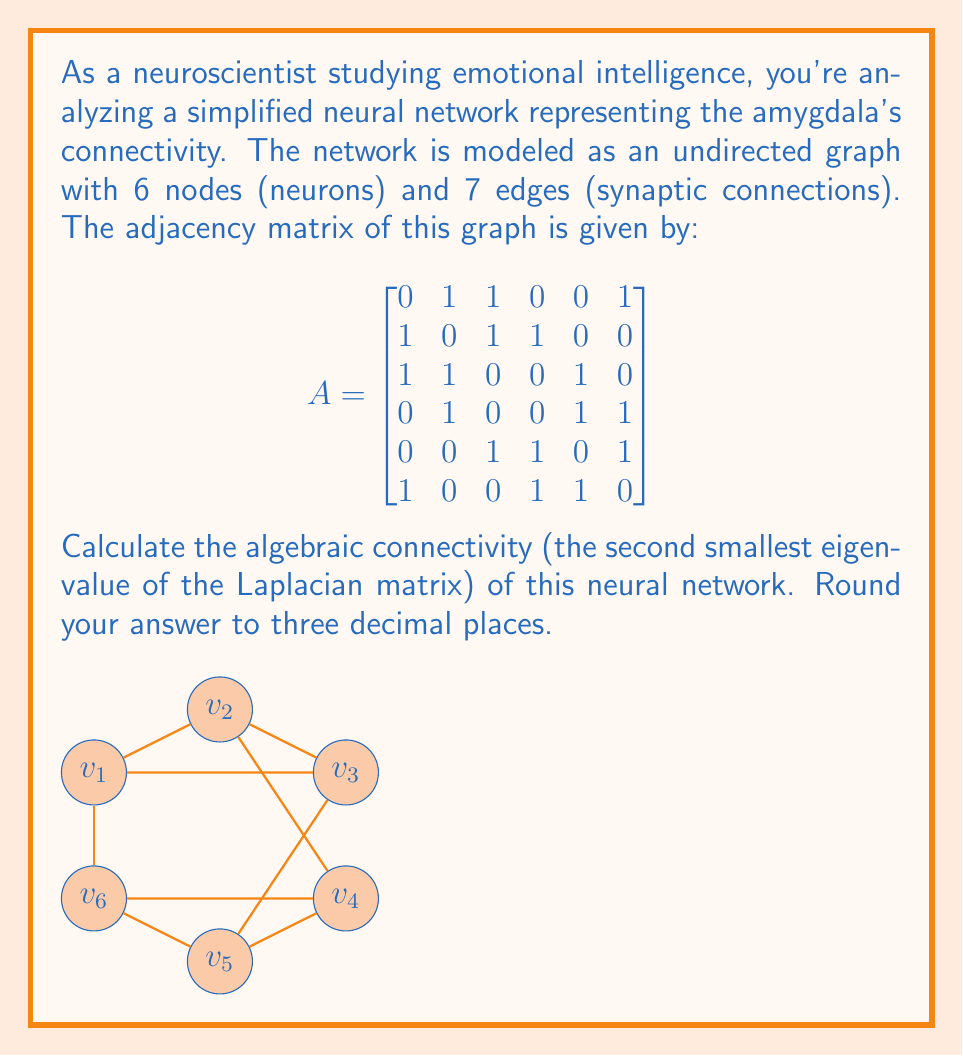Solve this math problem. To solve this problem, we'll follow these steps:

1) First, we need to compute the Laplacian matrix L from the adjacency matrix A.
   $L = D - A$, where D is the degree matrix.

2) The degree matrix D is a diagonal matrix where $D_{ii}$ is the degree of vertex i:
   $$D = \begin{bmatrix}
   3 & 0 & 0 & 0 & 0 & 0 \\
   0 & 3 & 0 & 0 & 0 & 0 \\
   0 & 0 & 3 & 0 & 0 & 0 \\
   0 & 0 & 0 & 3 & 0 & 0 \\
   0 & 0 & 0 & 0 & 3 & 0 \\
   0 & 0 & 0 & 0 & 0 & 3
   \end{bmatrix}$$

3) Now we can compute the Laplacian matrix:
   $$L = D - A = \begin{bmatrix}
   3 & -1 & -1 & 0 & 0 & -1 \\
   -1 & 3 & -1 & -1 & 0 & 0 \\
   -1 & -1 & 3 & 0 & -1 & 0 \\
   0 & -1 & 0 & 3 & -1 & -1 \\
   0 & 0 & -1 & -1 & 3 & -1 \\
   -1 & 0 & 0 & -1 & -1 & 3
   \end{bmatrix}$$

4) We need to find the eigenvalues of L. The characteristic equation is:
   $det(L - \lambda I) = 0$

5) Solving this equation (typically using a computer algebra system due to its complexity) gives us the eigenvalues:
   $\lambda_1 = 0$
   $\lambda_2 = 1.2679$
   $\lambda_3 = 3$
   $\lambda_4 = 3$
   $\lambda_5 = 4$
   $\lambda_6 = 4.7321$

6) The algebraic connectivity is the second smallest eigenvalue, which is $\lambda_2 = 1.2679$.

7) Rounding to three decimal places gives 1.268.
Answer: 1.268 